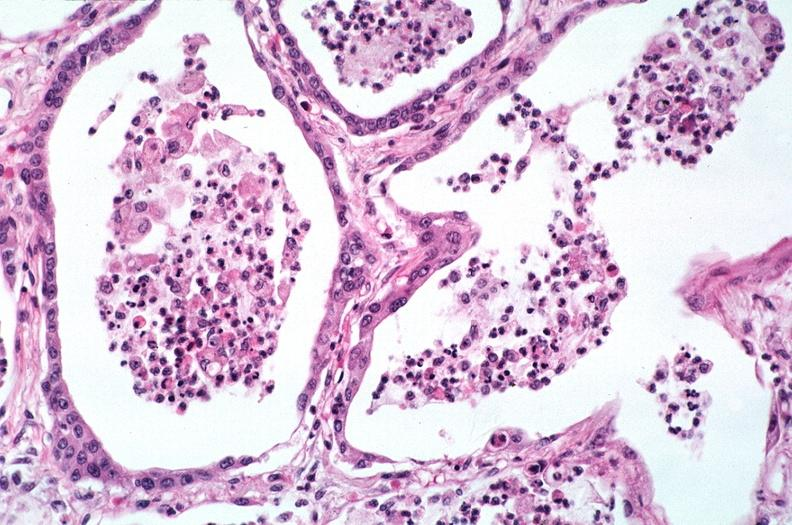s respiratory present?
Answer the question using a single word or phrase. Yes 